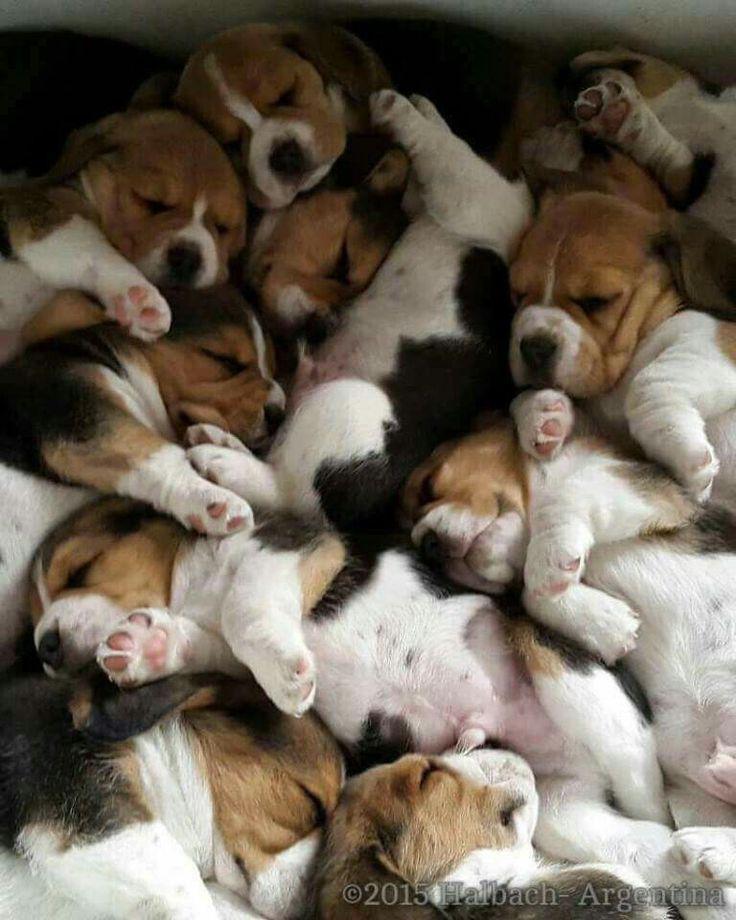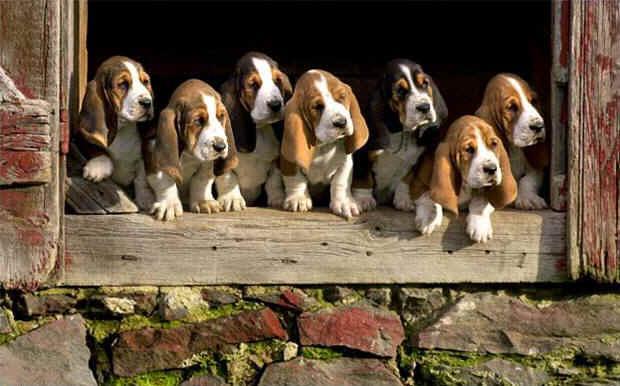The first image is the image on the left, the second image is the image on the right. Given the left and right images, does the statement "A single dog is standing on the ground in the image on the right." hold true? Answer yes or no. No. The first image is the image on the left, the second image is the image on the right. For the images displayed, is the sentence "One image shows a beagle standing on all fours with no other being present, and the other image shows at least 8 beagles, which are not in a single row." factually correct? Answer yes or no. No. 